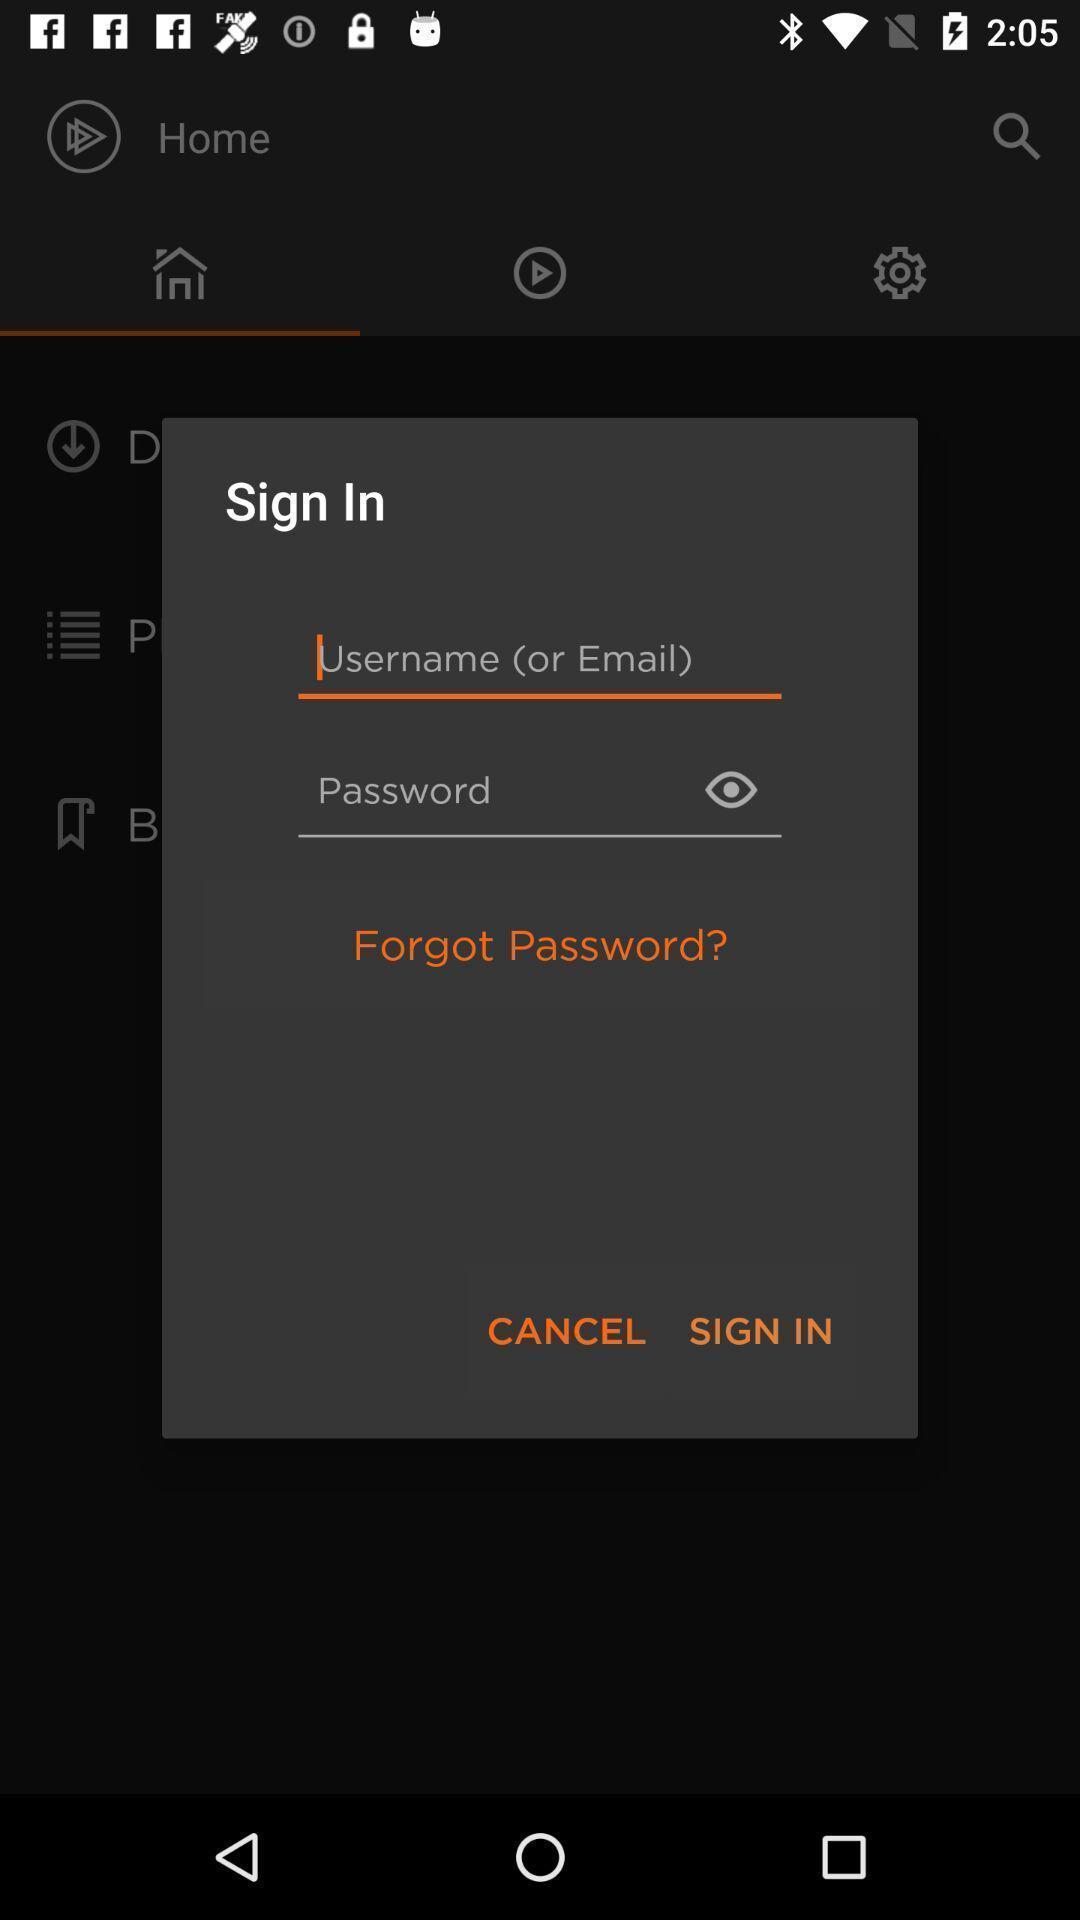Give me a summary of this screen capture. Popup of sign in page to get access in application. 